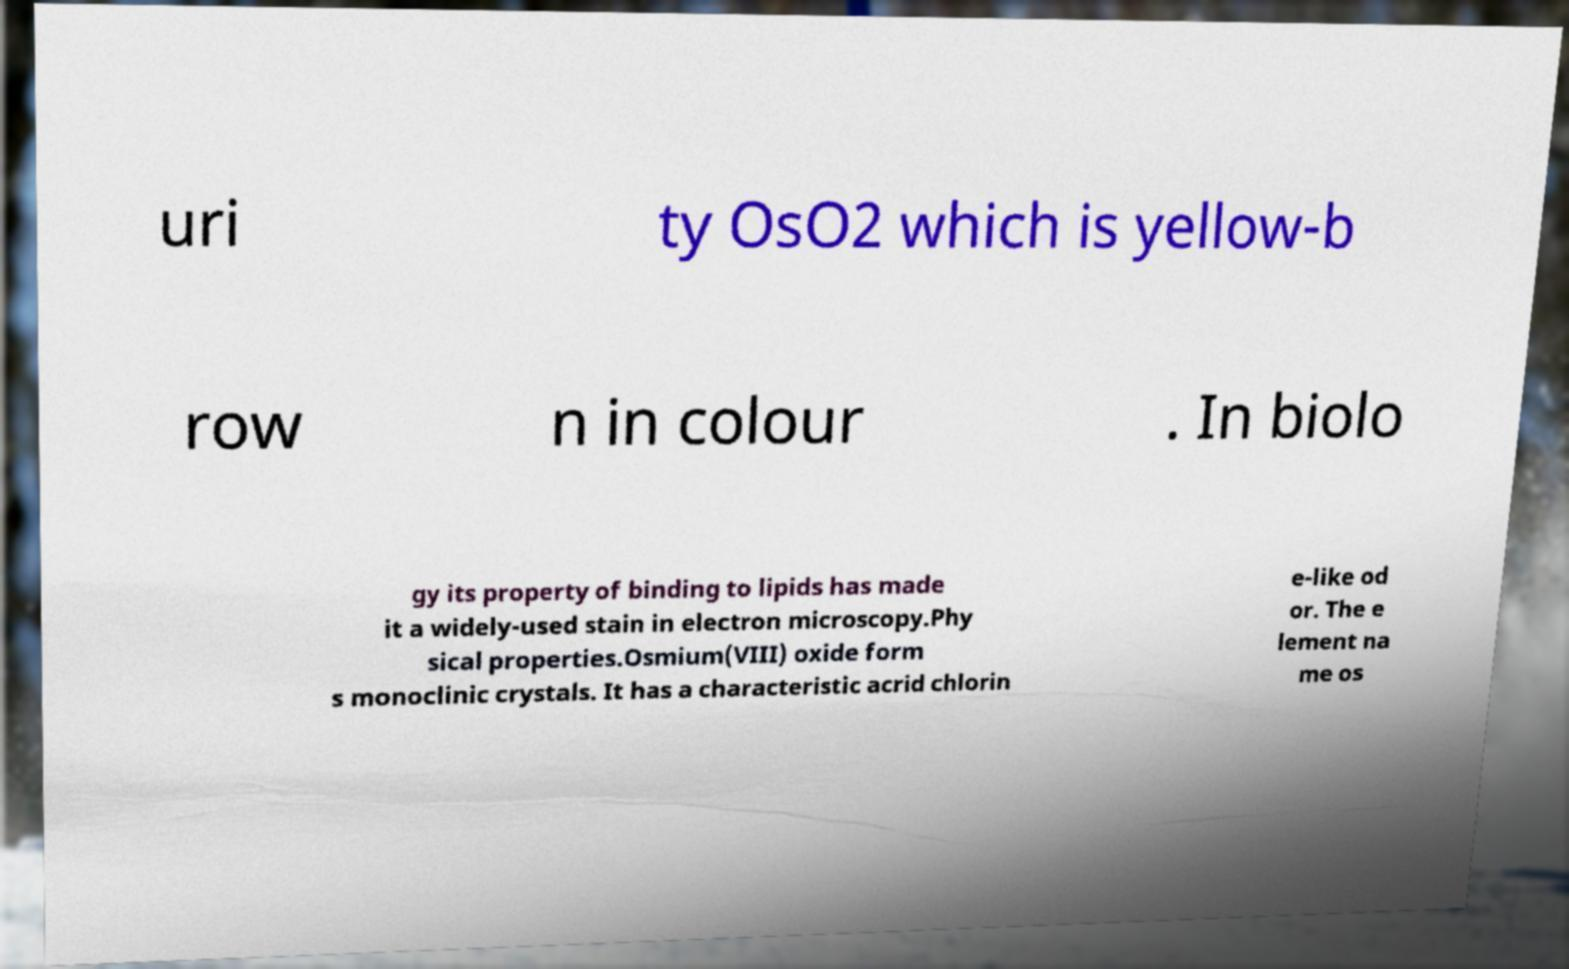Please read and relay the text visible in this image. What does it say? uri ty OsO2 which is yellow-b row n in colour . In biolo gy its property of binding to lipids has made it a widely-used stain in electron microscopy.Phy sical properties.Osmium(VIII) oxide form s monoclinic crystals. It has a characteristic acrid chlorin e-like od or. The e lement na me os 